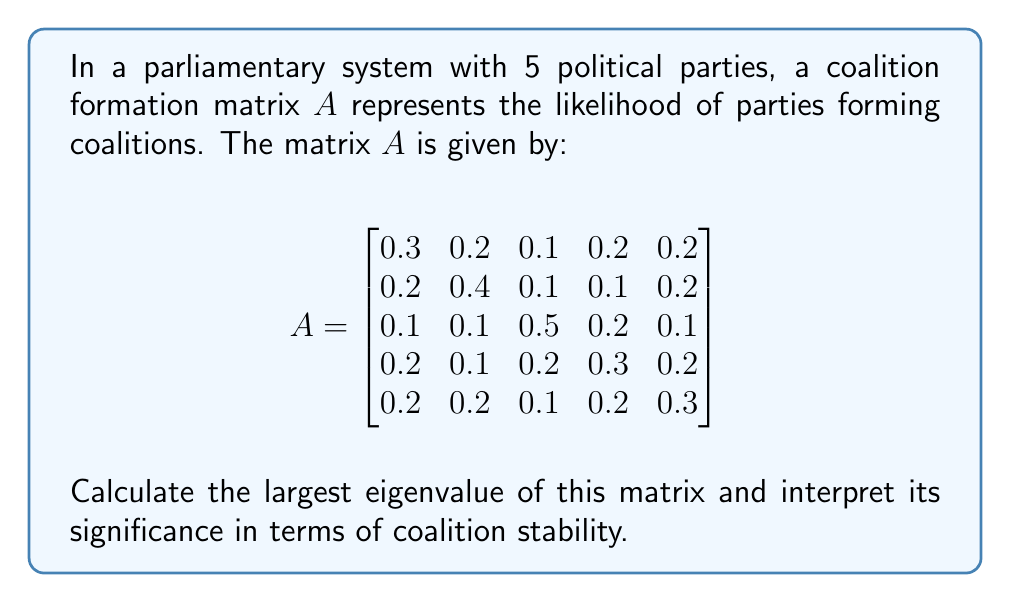Can you answer this question? To solve this problem, we'll follow these steps:

1) First, we need to find the characteristic equation of the matrix $A$:
   $det(A - \lambda I) = 0$

2) Expanding this determinant gives us a 5th degree polynomial equation:
   $\lambda^5 - 1.8\lambda^4 + 0.959\lambda^3 - 0.2298\lambda^2 + 0.02454\lambda - 0.000972 = 0$

3) This equation is too complex to solve by hand, so we'll use numerical methods. Using a computer algebra system or numerical solver, we find the roots of this equation, which are the eigenvalues of $A$:

   $\lambda_1 \approx 1.0000$
   $\lambda_2 \approx 0.3500 + 0.0866i$
   $\lambda_3 \approx 0.3500 - 0.0866i$
   $\lambda_4 \approx 0.0500 + 0.0866i$
   $\lambda_5 \approx 0.0500 - 0.0866i$

4) The largest eigenvalue is $\lambda_1 \approx 1.0000$

5) Interpretation: In coalition formation matrices, the largest eigenvalue (also known as the Perron-Frobenius eigenvalue) represents the long-term stability of the coalition system. A value of 1 indicates a perfectly balanced system where coalitions are likely to remain stable over time. Values significantly greater than 1 suggest instability, while values less than 1 indicate a tendency towards a dominant coalition.

In this case, the largest eigenvalue is very close to 1, indicating a highly stable coalition system. This suggests that the current distribution of coalition probabilities is likely to persist, with no single coalition dominating in the long run.
Answer: $\lambda_{max} \approx 1.0000$, indicating a stable coalition system. 